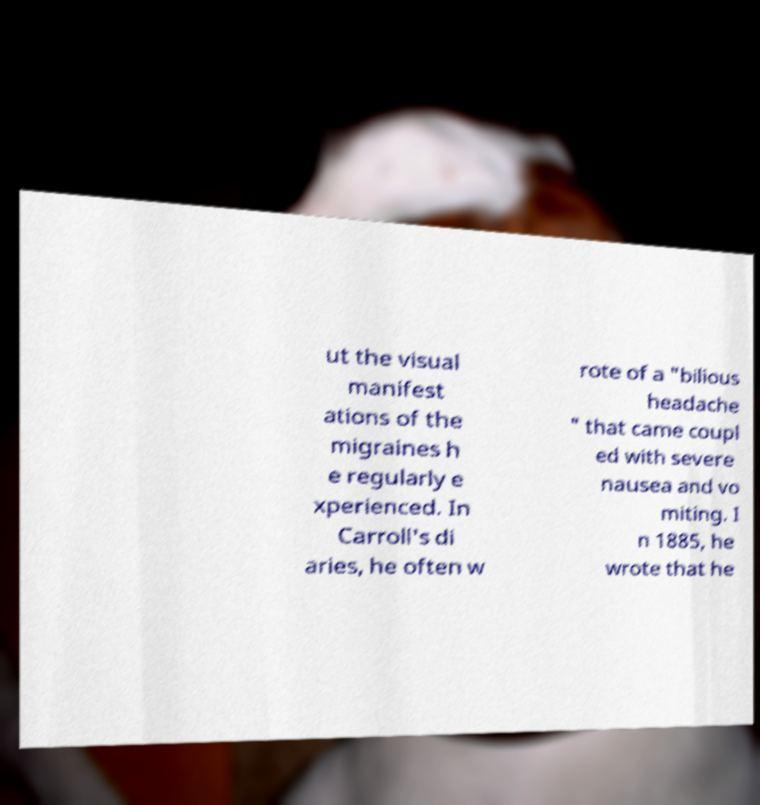Could you extract and type out the text from this image? ut the visual manifest ations of the migraines h e regularly e xperienced. In Carroll's di aries, he often w rote of a "bilious headache " that came coupl ed with severe nausea and vo miting. I n 1885, he wrote that he 